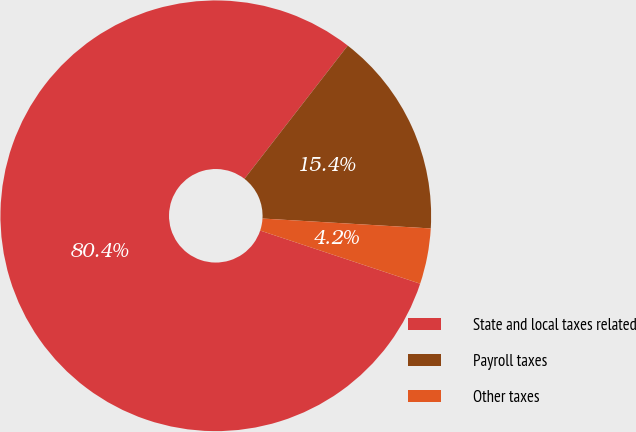<chart> <loc_0><loc_0><loc_500><loc_500><pie_chart><fcel>State and local taxes related<fcel>Payroll taxes<fcel>Other taxes<nl><fcel>80.39%<fcel>15.44%<fcel>4.17%<nl></chart> 